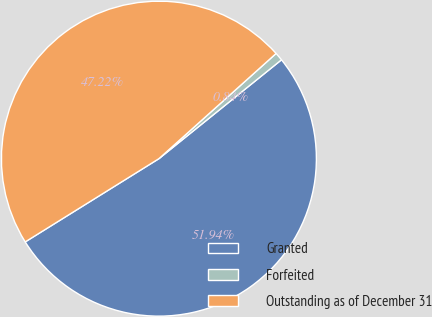Convert chart. <chart><loc_0><loc_0><loc_500><loc_500><pie_chart><fcel>Granted<fcel>Forfeited<fcel>Outstanding as of December 31<nl><fcel>51.94%<fcel>0.84%<fcel>47.22%<nl></chart> 